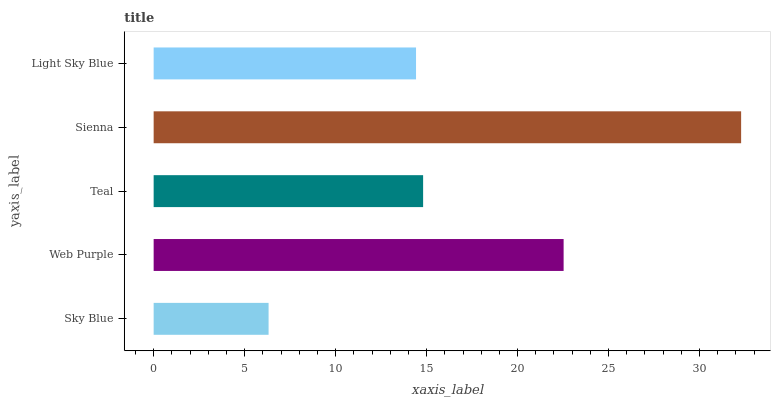Is Sky Blue the minimum?
Answer yes or no. Yes. Is Sienna the maximum?
Answer yes or no. Yes. Is Web Purple the minimum?
Answer yes or no. No. Is Web Purple the maximum?
Answer yes or no. No. Is Web Purple greater than Sky Blue?
Answer yes or no. Yes. Is Sky Blue less than Web Purple?
Answer yes or no. Yes. Is Sky Blue greater than Web Purple?
Answer yes or no. No. Is Web Purple less than Sky Blue?
Answer yes or no. No. Is Teal the high median?
Answer yes or no. Yes. Is Teal the low median?
Answer yes or no. Yes. Is Sky Blue the high median?
Answer yes or no. No. Is Light Sky Blue the low median?
Answer yes or no. No. 